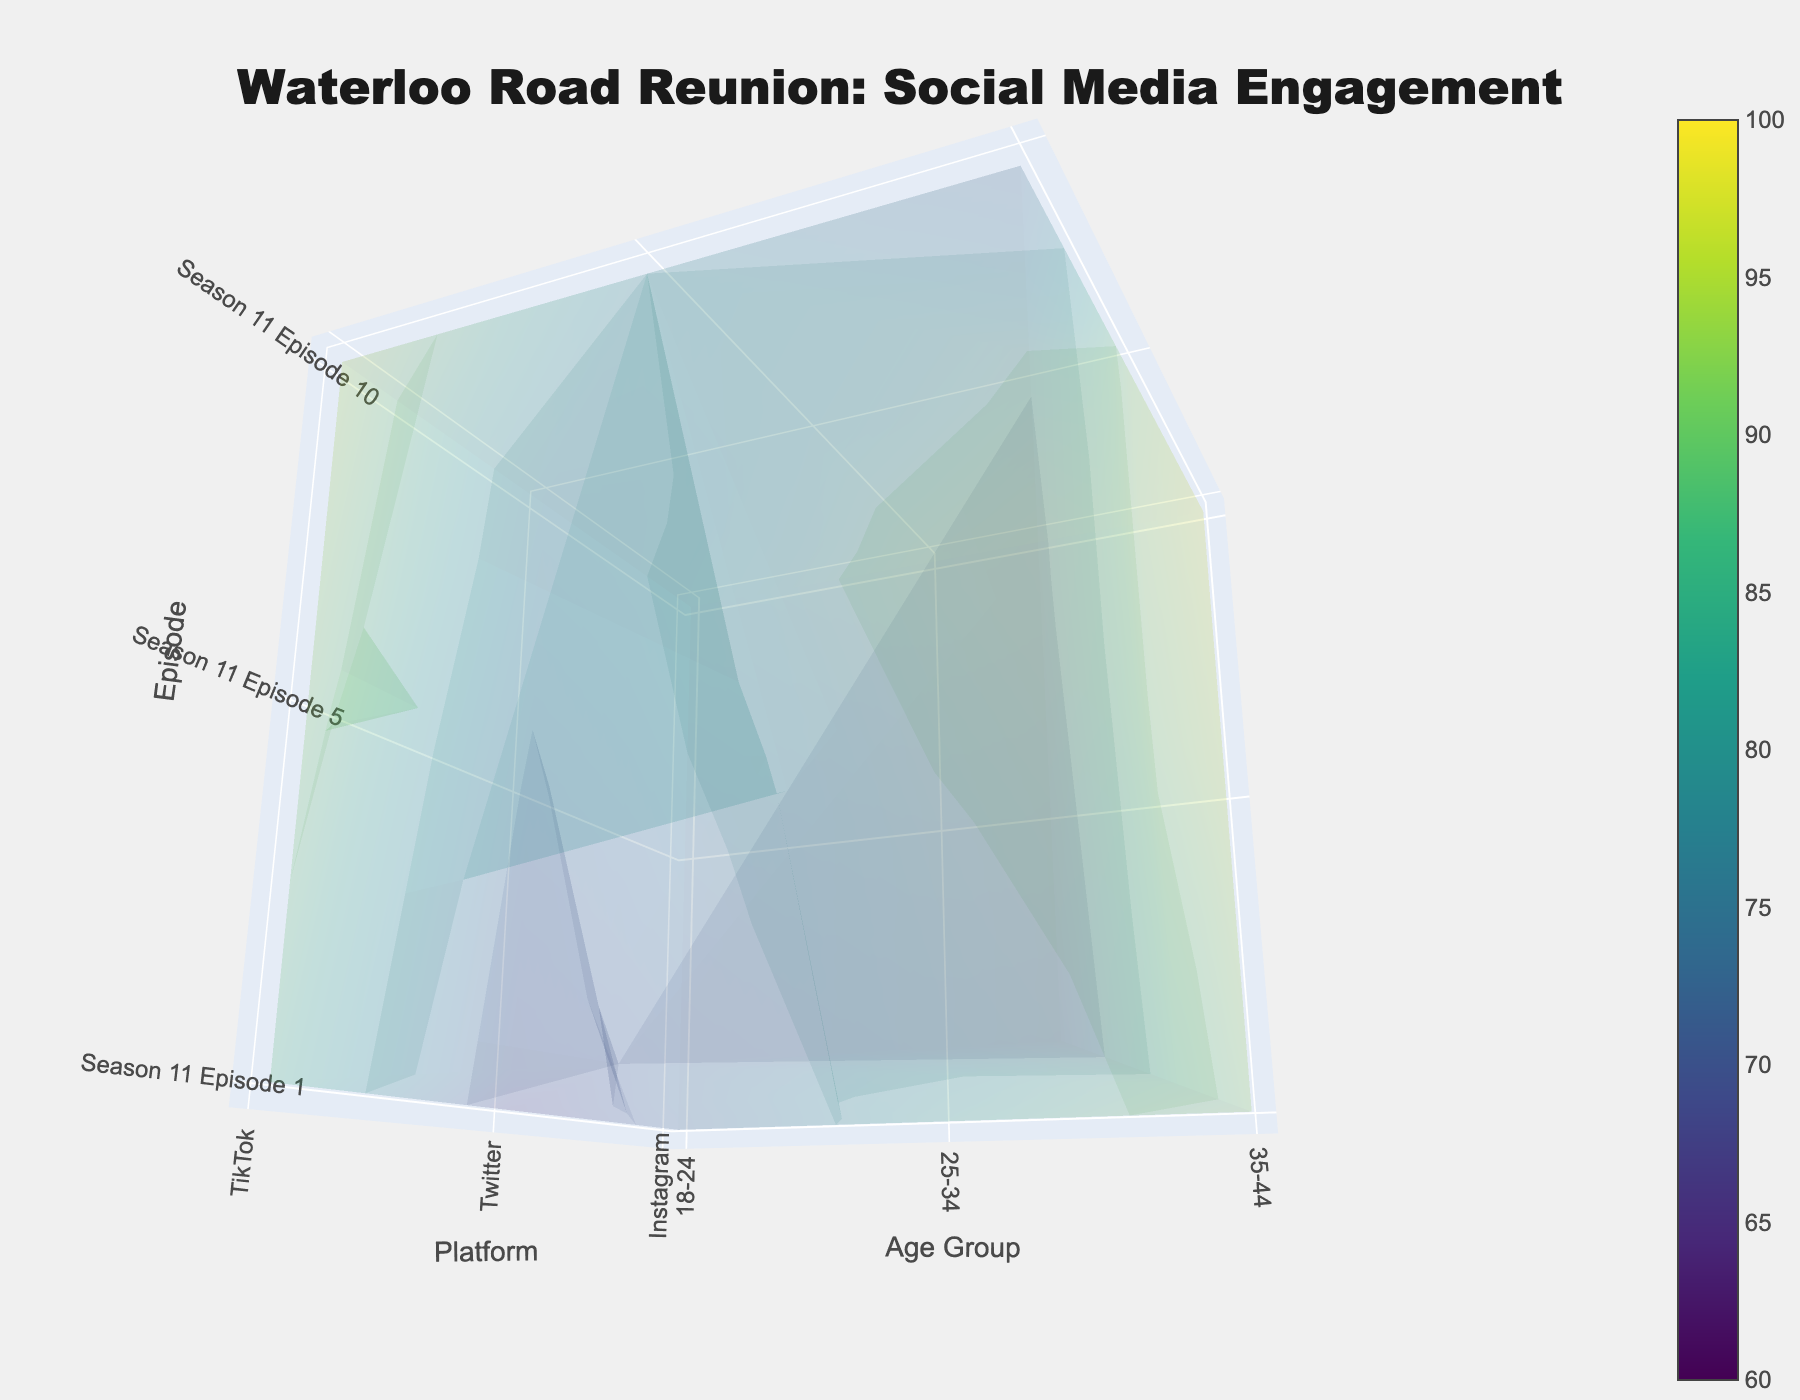What is the title of the figure? The title of the figure is located at the top and is generally larger and bold compared to other text on the plot. It provides a summary of what the plot is about. By looking at the rendered image, we see a title explaining social media engagement data for Waterloo Road reunion episodes.
Answer: "Waterloo Road Reunion: Social Media Engagement" What are the axes representing in this plot? The axes of this 3D volume plot are labeled to represent three different categories. The x-axis represents platforms, the y-axis represents age groups, and the z-axis represents episodes. These labels are typically found next to the corresponding axes.
Answer: Platforms, Age Groups, Episodes Which episode has the highest engagement score among the 35-44 age group on Instagram? By identifying the points corresponding to the 35-44 age group and Instagram platform, we look across the z-axis for episodes and check the values. Comparing these values, the highest engagement score is observed for Season 11 Episode 10.
Answer: Season 11 Episode 10 How does the engagement score on Twitter for the 18-24 age group change across episodes? We need to extract the engagement scores on Twitter specifically for the 18-24 age group and then observe their scores across the episodes on the z-axis. The scores for the respective episodes are 65 (Episode 1), 69 (Episode 5), and 74 (Episode 10), showing an increasing trend.
Answer: Increasing (65, 69, 74) Which platform had the highest engagement in Season 11 Episode 5 for the 25-34 age group? For Season 11 Episode 5 and the 25-34 age group, we compare the engagement scores across Instagram, Twitter, and TikTok. The visual indicates that Instagram has the highest score among the platforms for this specific episode and age group.
Answer: Instagram What is the average engagement score for TikTok across all episodes for the 35-44 age group? We list the engagement scores from TikTok for all episodes in the 35-44 age group, which are 62 (Episode 1), 68 (Episode 5), and 73 (Episode 10). We sum these values and divide by the number of episodes: (62 + 68 + 73) / 3 = 67.67.
Answer: 67.67 Compare the engagement scores between Instagram and TikTok for the 18-24 age group in Season 11 Episode 1. Identifying the points for the 18-24 age group in Season 11 Episode 1, Instagram has a score of 72, whereas TikTok has a higher score of 88. We compare these values.
Answer: TikTok has higher engagement (88 vs. 72) What trend do you observe in the engagement scores for the 25-34 age group across episodes? Observing the z-axis data points for the 25-34 age group, we examine how scores change in Instagram, Twitter, and TikTok across the episodes. Generally, there is an increasing trend in engagement scores across all platforms for this age group.
Answer: Increasing trend Do the engagement scores on Twitter for the 35-44 age group exceed 90 in any episode? By checking the engagement values on Twitter for the 35-44 age group across all episodes, we find scores of 87 (Episode 1), 91 (Episode 5), and 93 (Episode 10). Both Episodes 5 and 10 have scores exceeding 90.
Answer: Yes, in Episodes 5 and 10 How does the engagement score distribution vary across platforms for Season 11 Episode 1? We review the engagement scores for each platform in Season 11 Episode 1. For Instagram, Twitter, and TikTok, the scores are differentiated. Percentages or actual differences are calculated if needed to discern the variance.
Answer: Scores vary with Instagram (85), Twitter (79), TikTok (70) for 25-34 age 